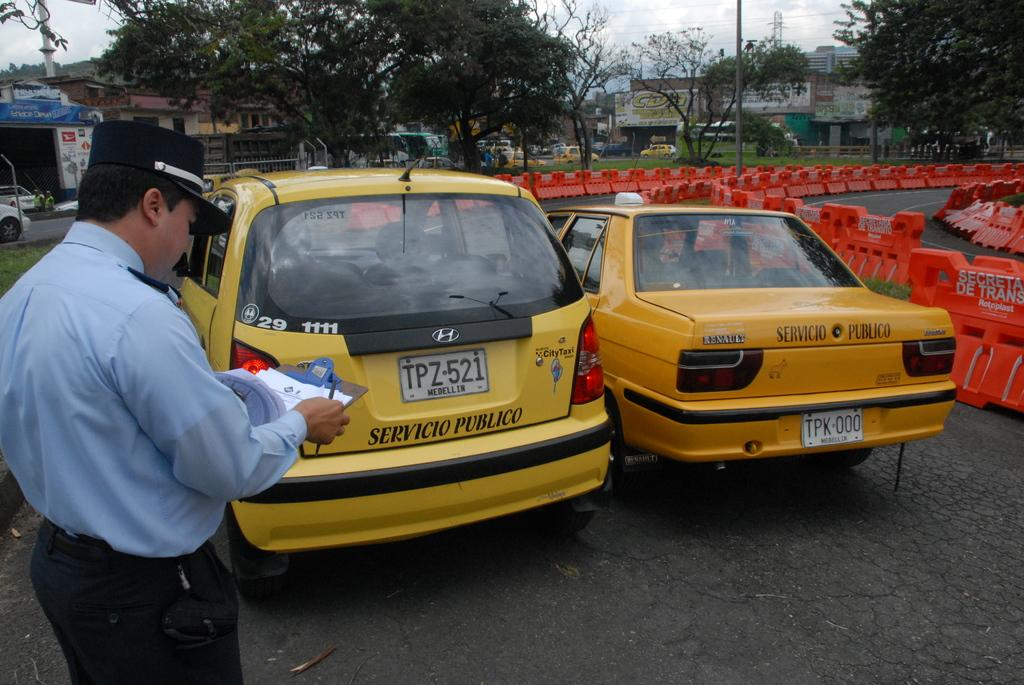Provide a one-sentence caption for the provided image. Two yellow vehicles with a man with a clipboard standing to the left. 